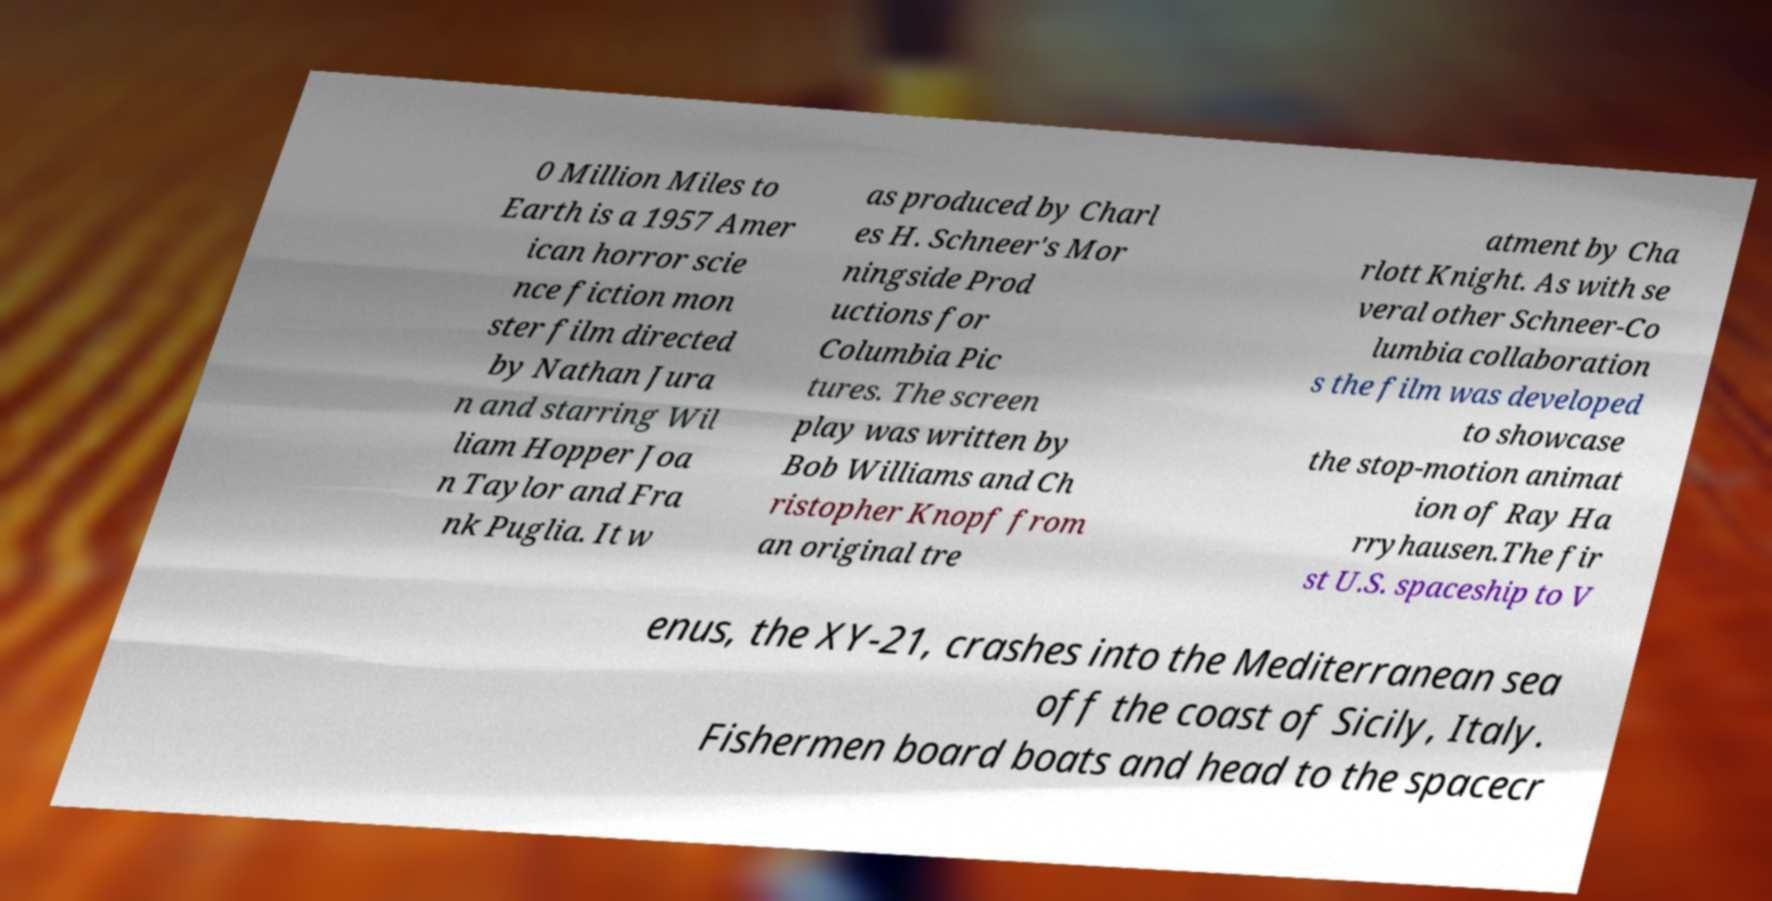Can you read and provide the text displayed in the image?This photo seems to have some interesting text. Can you extract and type it out for me? 0 Million Miles to Earth is a 1957 Amer ican horror scie nce fiction mon ster film directed by Nathan Jura n and starring Wil liam Hopper Joa n Taylor and Fra nk Puglia. It w as produced by Charl es H. Schneer's Mor ningside Prod uctions for Columbia Pic tures. The screen play was written by Bob Williams and Ch ristopher Knopf from an original tre atment by Cha rlott Knight. As with se veral other Schneer-Co lumbia collaboration s the film was developed to showcase the stop-motion animat ion of Ray Ha rryhausen.The fir st U.S. spaceship to V enus, the XY-21, crashes into the Mediterranean sea off the coast of Sicily, Italy. Fishermen board boats and head to the spacecr 